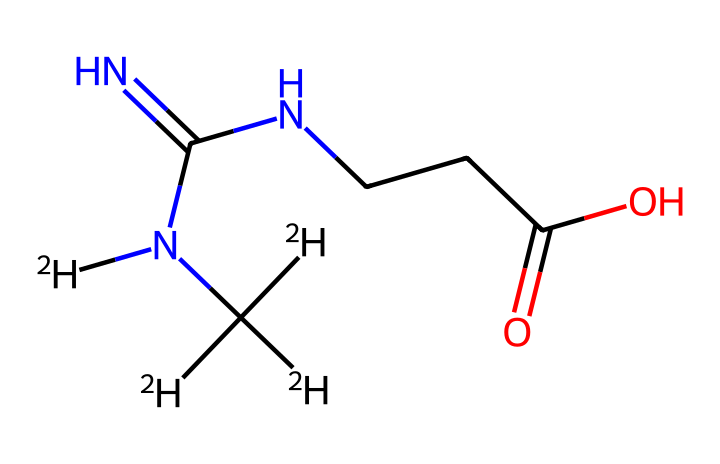what is the molecular formula of deuterated creatine supplements? To find the molecular formula, we count the types and numbers of atoms present in the compound. In the SMILES representation, we identify 2 nitrogen (N) atoms, 5 hydrogen (H) atoms (denoted as [2H] for deuterium), 6 carbon (C) atoms, and 2 oxygen (O) atoms. Therefore, the molecular formula, summarized from the counts of each type of atom, is C6H12N4O2.
Answer: C6H12N4O2 how many nitrogen atoms are in the chemical structure? By analyzing the SMILES representation, we clearly see that there are 4 nitrogen (N) atoms present in the formula. Each 'N' in the structure corresponds to a nitrogen atom.
Answer: 4 what type of isotopes are present in this compound? The SMILES shows the presence of deuterium, represented as [2H], indicating that hydrogen atoms in this compound are actually deuterium isotopes rather than ordinary hydrogen.
Answer: deuterium how many distinct types of atoms are in this structure? In the given SMILES, there are 4 types of atoms: carbon (C), hydrogen (H), nitrogen (N), and oxygen (O). We can verify this by counting the different elemental symbols in the representation.
Answer: 4 does this compound include any chiral centers? To determine chirality, we look for carbon atoms bonded to four different substituents. In this chemical structure, none of the carbon atoms meet this criterion, indicating that there are no chiral centers.
Answer: no what structural feature indicates that this compound is a creatine derivative? The presence of a guanidine group (C(=N)N) along with a carboxyl group (-COOH) in the structure is characteristic of creatine and shows that this compound is a derivative of creatine.
Answer: guanidine group 